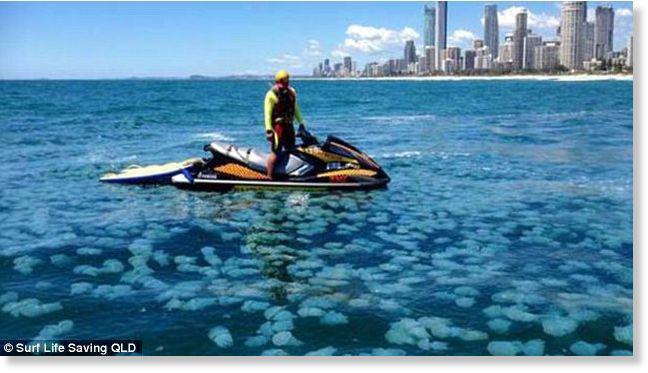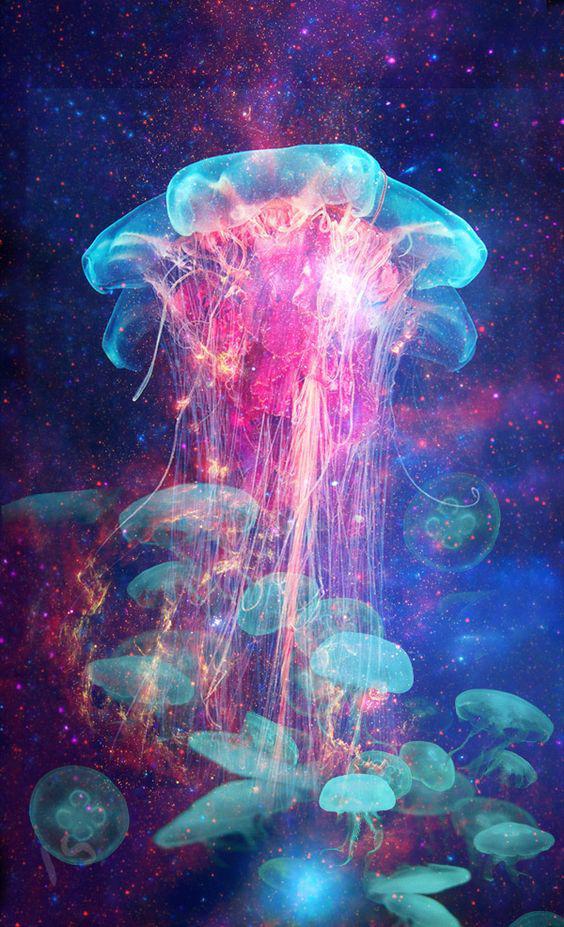The first image is the image on the left, the second image is the image on the right. For the images displayed, is the sentence "The left image shows masses of light blue jellyfish viewed from above the water's surface, with a city horizon in the background." factually correct? Answer yes or no. Yes. The first image is the image on the left, the second image is the image on the right. Examine the images to the left and right. Is the description "there are many jellyfish being viewed from above water in daylight hours" accurate? Answer yes or no. Yes. 